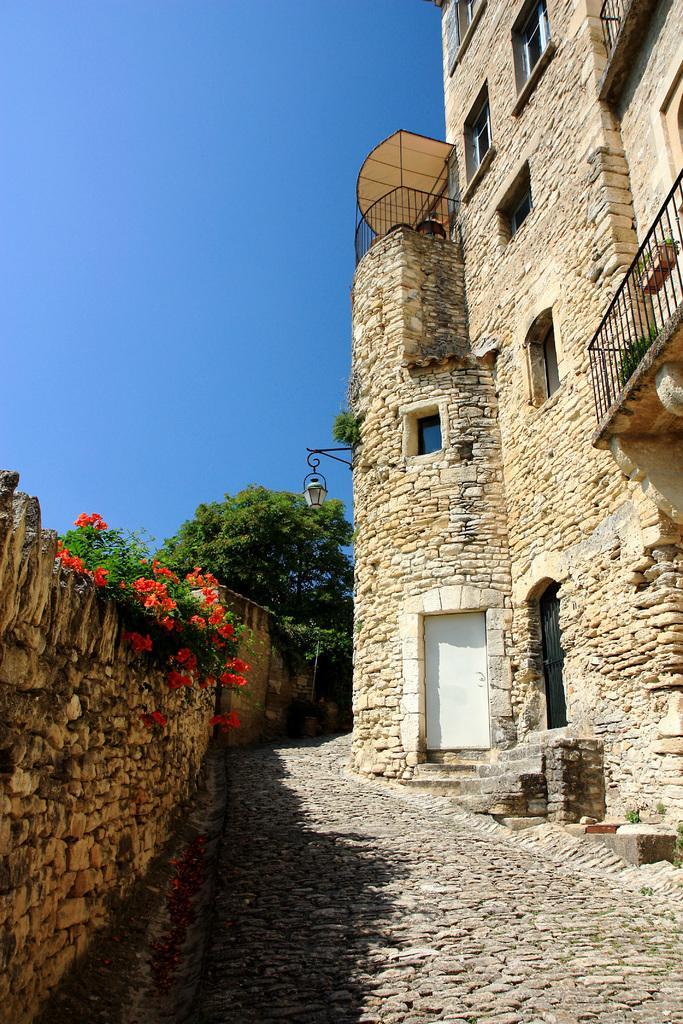Can you describe this image briefly? In this image, we can see a building and there are railings and flower pots and a light and we can see a wall and some plants and trees. At the bottom, there is a road and at the top, there is sky. 